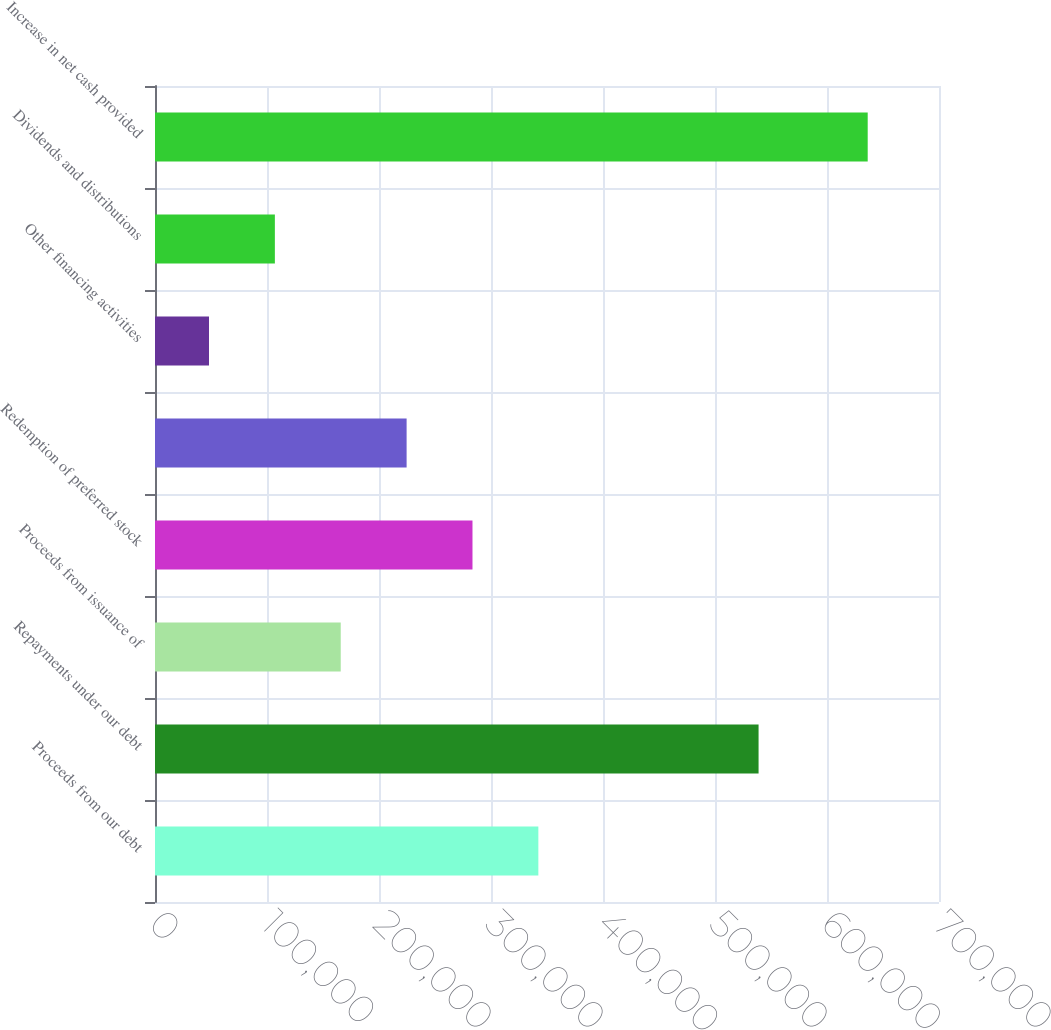Convert chart to OTSL. <chart><loc_0><loc_0><loc_500><loc_500><bar_chart><fcel>Proceeds from our debt<fcel>Repayments under our debt<fcel>Proceeds from issuance of<fcel>Redemption of preferred stock<fcel>Unnamed: 4<fcel>Other financing activities<fcel>Dividends and distributions<fcel>Increase in net cash provided<nl><fcel>342278<fcel>538903<fcel>165839<fcel>283465<fcel>224652<fcel>48213<fcel>107026<fcel>636343<nl></chart> 